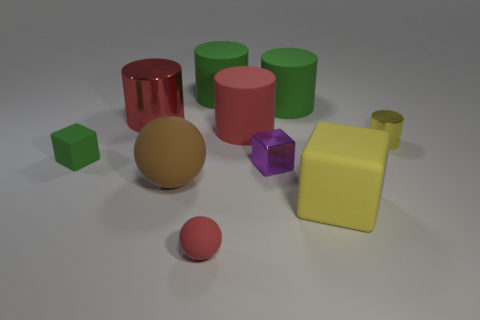Do the red thing that is to the left of the red ball and the tiny purple block have the same material?
Make the answer very short. Yes. How many other things are made of the same material as the large block?
Provide a succinct answer. 6. There is a red thing that is the same size as the purple cube; what is its material?
Offer a terse response. Rubber. There is a thing that is in front of the big yellow matte object; does it have the same shape as the red thing that is to the right of the tiny red rubber object?
Provide a succinct answer. No. The red metallic thing that is the same size as the brown rubber object is what shape?
Your answer should be compact. Cylinder. Are the red cylinder to the right of the brown sphere and the small block that is left of the purple thing made of the same material?
Your answer should be compact. Yes. Is there a tiny rubber sphere in front of the tiny metal thing that is left of the small metallic cylinder?
Your answer should be compact. Yes. There is another big cylinder that is the same material as the yellow cylinder; what color is it?
Make the answer very short. Red. Are there more metallic cylinders than tiny purple metallic blocks?
Give a very brief answer. Yes. How many things are either red objects that are behind the purple thing or rubber things?
Ensure brevity in your answer.  8. 